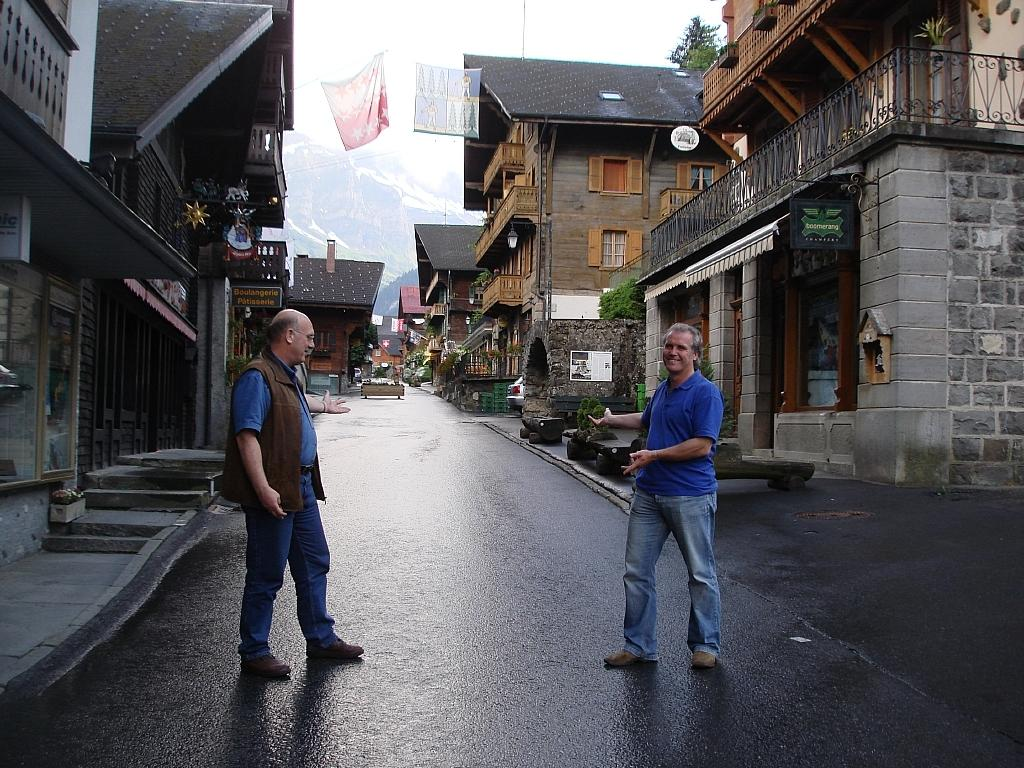How many people are on the road in the image? There are two people on the road in the image. What else can be seen in the image besides the people on the road? There are buildings, plants, a tree, objects near the road, and a mountain covered with snow in the image. What type of flower is growing on the aunt's hat in the image? There is no aunt or hat present in the image, so it is not possible to determine if there are any flowers on a hat. 